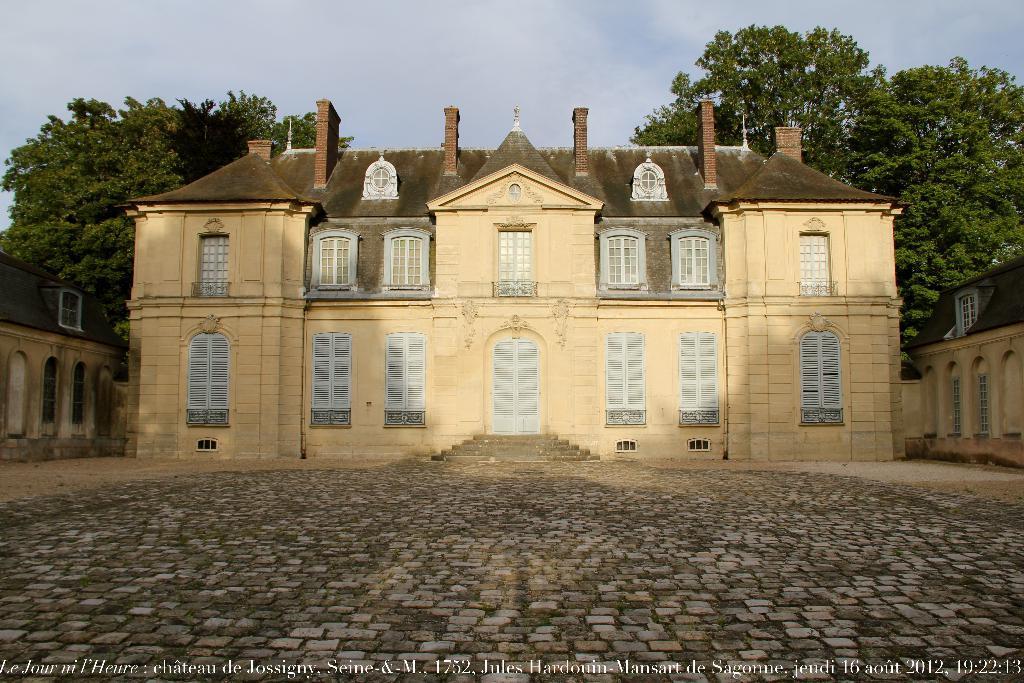Could you give a brief overview of what you see in this image? In this picture we can see tiles on the ground and buildings. In the background of the image we can see trees and sky. At the bottom of the image we can see text. 